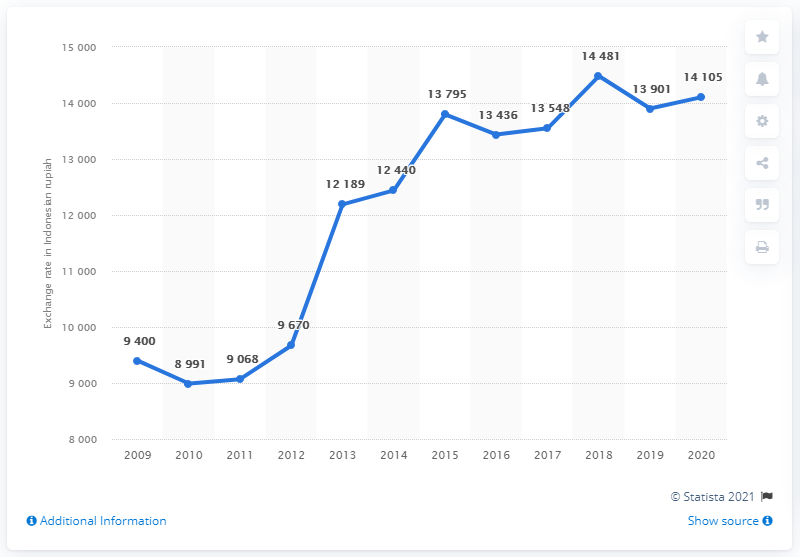Point out several critical features in this image. In 2020, the average exchange rate from Indonesian rupiah to U.S. dollars was 14,105. The average exchange rate of Indonesian rupiahs from 2019 to 2020 was approximately 14003. In 2020, the average exchange rate from Indonesian rupiah to U.S. dollars was 14,105. In 2018, the exchange rate of Indonesian Rupiahs was 14,481. 